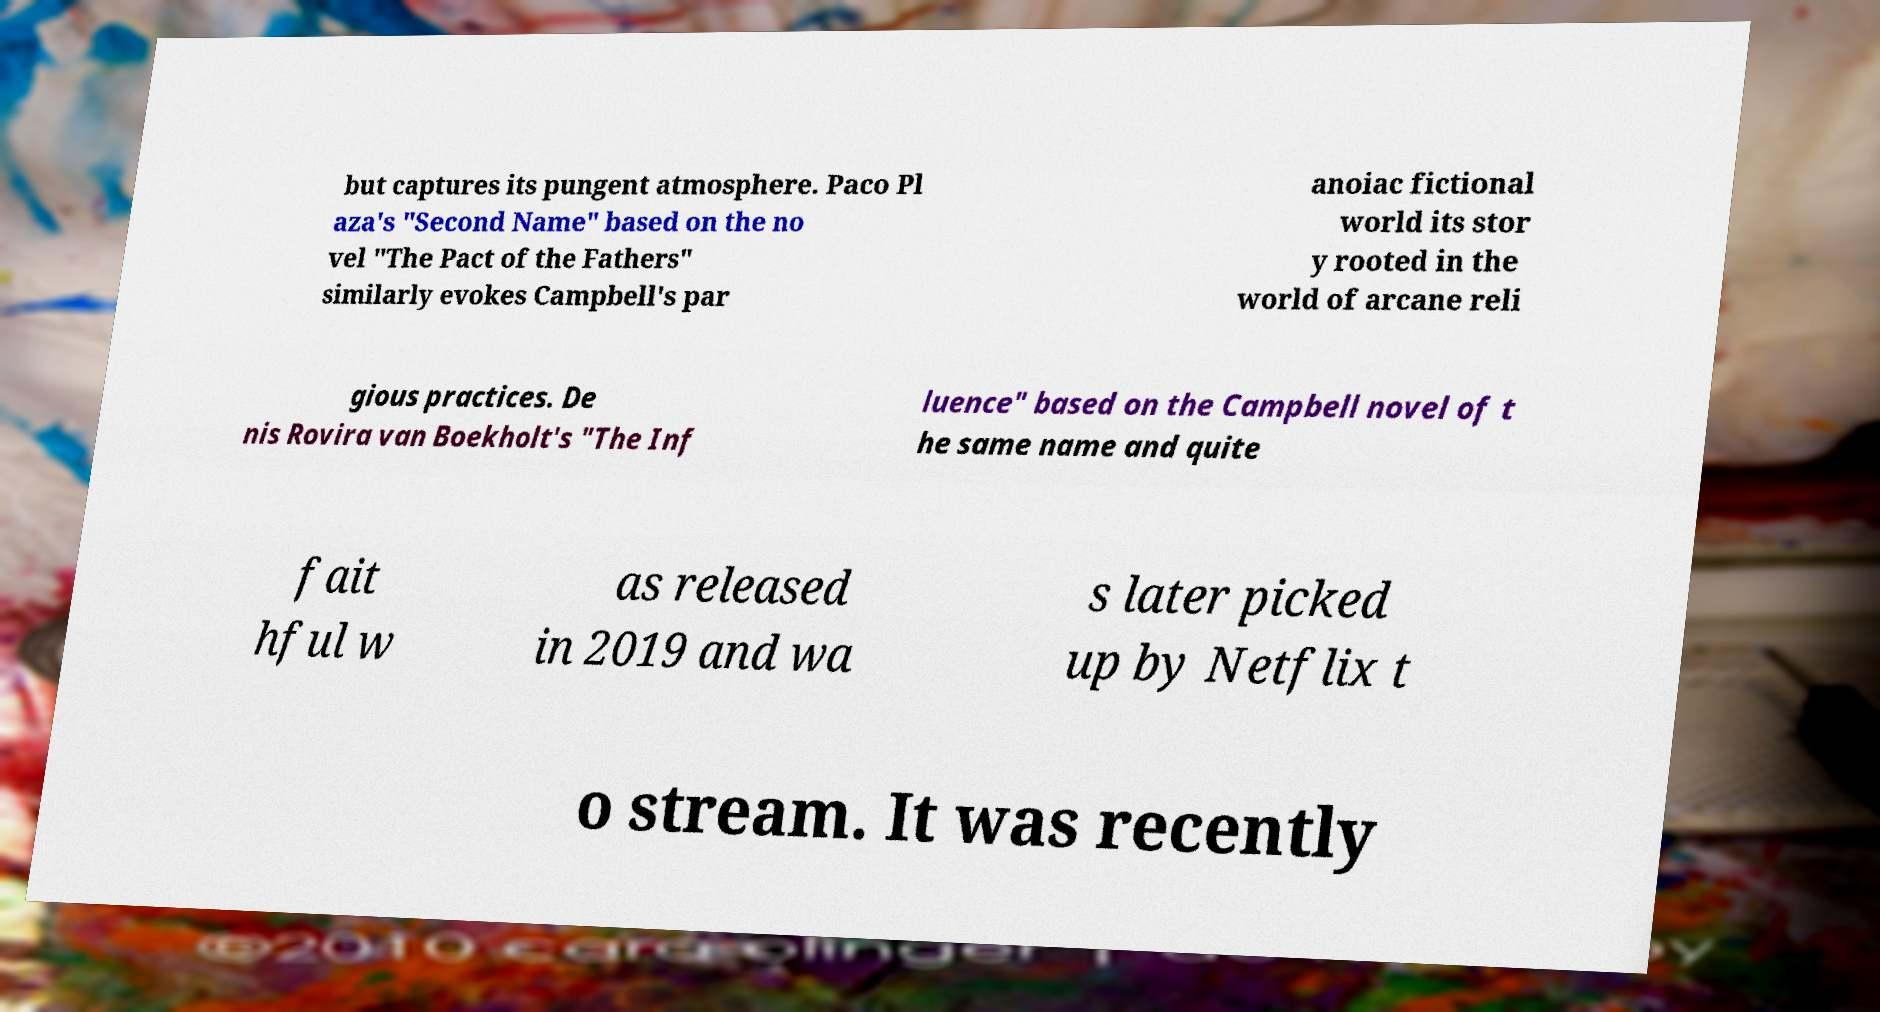I need the written content from this picture converted into text. Can you do that? but captures its pungent atmosphere. Paco Pl aza's "Second Name" based on the no vel "The Pact of the Fathers" similarly evokes Campbell's par anoiac fictional world its stor y rooted in the world of arcane reli gious practices. De nis Rovira van Boekholt's "The Inf luence" based on the Campbell novel of t he same name and quite fait hful w as released in 2019 and wa s later picked up by Netflix t o stream. It was recently 